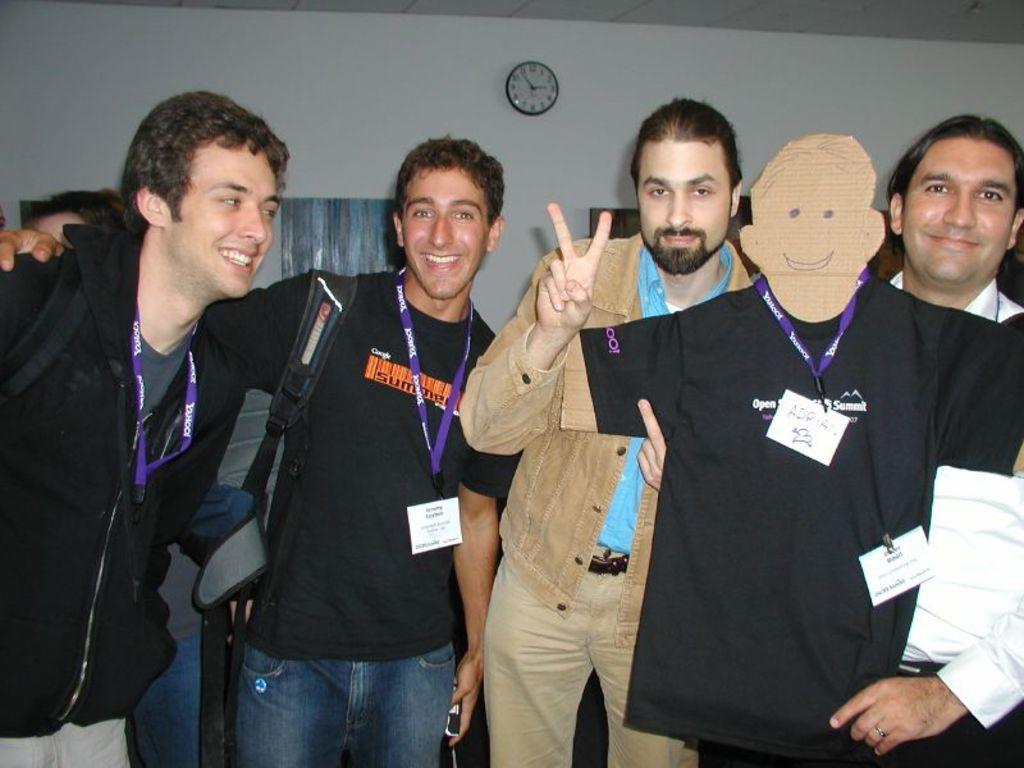How would you summarize this image in a sentence or two? There are four men standing and smiling. This is a cutout of the man with a badge and T-shirt. I can see a wall clock, which is attached to the wall. I think this is a frame. 